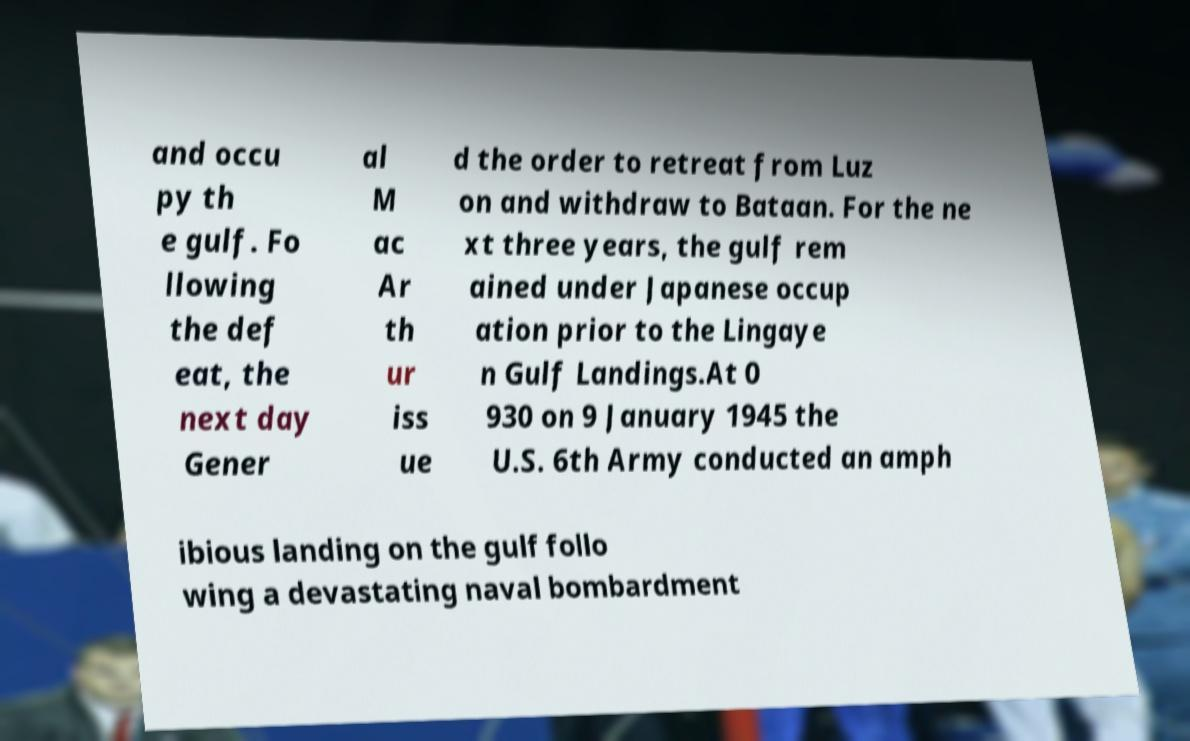What messages or text are displayed in this image? I need them in a readable, typed format. and occu py th e gulf. Fo llowing the def eat, the next day Gener al M ac Ar th ur iss ue d the order to retreat from Luz on and withdraw to Bataan. For the ne xt three years, the gulf rem ained under Japanese occup ation prior to the Lingaye n Gulf Landings.At 0 930 on 9 January 1945 the U.S. 6th Army conducted an amph ibious landing on the gulf follo wing a devastating naval bombardment 